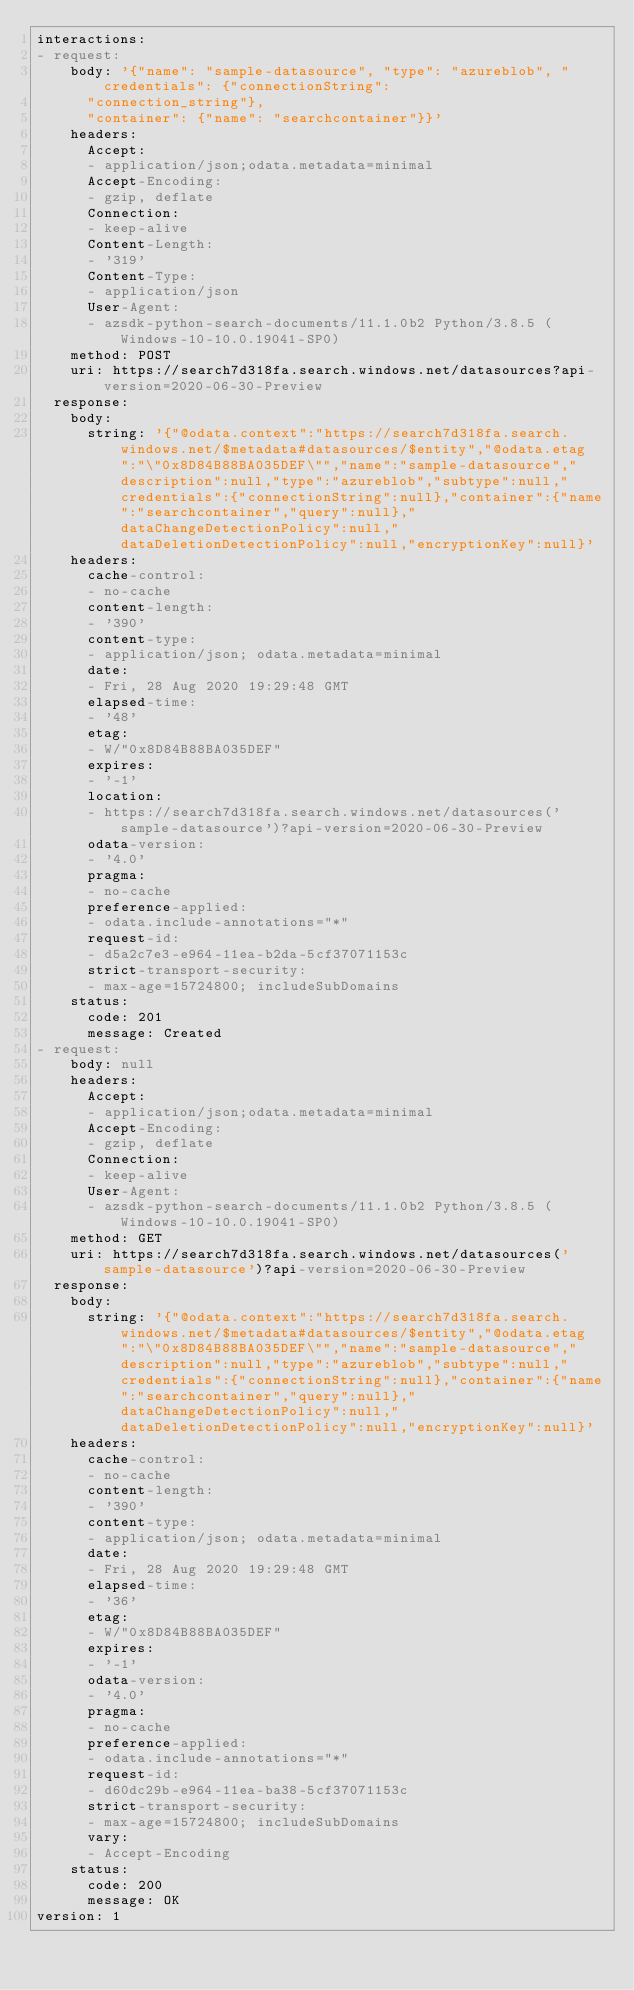Convert code to text. <code><loc_0><loc_0><loc_500><loc_500><_YAML_>interactions:
- request:
    body: '{"name": "sample-datasource", "type": "azureblob", "credentials": {"connectionString":
      "connection_string"},
      "container": {"name": "searchcontainer"}}'
    headers:
      Accept:
      - application/json;odata.metadata=minimal
      Accept-Encoding:
      - gzip, deflate
      Connection:
      - keep-alive
      Content-Length:
      - '319'
      Content-Type:
      - application/json
      User-Agent:
      - azsdk-python-search-documents/11.1.0b2 Python/3.8.5 (Windows-10-10.0.19041-SP0)
    method: POST
    uri: https://search7d318fa.search.windows.net/datasources?api-version=2020-06-30-Preview
  response:
    body:
      string: '{"@odata.context":"https://search7d318fa.search.windows.net/$metadata#datasources/$entity","@odata.etag":"\"0x8D84B88BA035DEF\"","name":"sample-datasource","description":null,"type":"azureblob","subtype":null,"credentials":{"connectionString":null},"container":{"name":"searchcontainer","query":null},"dataChangeDetectionPolicy":null,"dataDeletionDetectionPolicy":null,"encryptionKey":null}'
    headers:
      cache-control:
      - no-cache
      content-length:
      - '390'
      content-type:
      - application/json; odata.metadata=minimal
      date:
      - Fri, 28 Aug 2020 19:29:48 GMT
      elapsed-time:
      - '48'
      etag:
      - W/"0x8D84B88BA035DEF"
      expires:
      - '-1'
      location:
      - https://search7d318fa.search.windows.net/datasources('sample-datasource')?api-version=2020-06-30-Preview
      odata-version:
      - '4.0'
      pragma:
      - no-cache
      preference-applied:
      - odata.include-annotations="*"
      request-id:
      - d5a2c7e3-e964-11ea-b2da-5cf37071153c
      strict-transport-security:
      - max-age=15724800; includeSubDomains
    status:
      code: 201
      message: Created
- request:
    body: null
    headers:
      Accept:
      - application/json;odata.metadata=minimal
      Accept-Encoding:
      - gzip, deflate
      Connection:
      - keep-alive
      User-Agent:
      - azsdk-python-search-documents/11.1.0b2 Python/3.8.5 (Windows-10-10.0.19041-SP0)
    method: GET
    uri: https://search7d318fa.search.windows.net/datasources('sample-datasource')?api-version=2020-06-30-Preview
  response:
    body:
      string: '{"@odata.context":"https://search7d318fa.search.windows.net/$metadata#datasources/$entity","@odata.etag":"\"0x8D84B88BA035DEF\"","name":"sample-datasource","description":null,"type":"azureblob","subtype":null,"credentials":{"connectionString":null},"container":{"name":"searchcontainer","query":null},"dataChangeDetectionPolicy":null,"dataDeletionDetectionPolicy":null,"encryptionKey":null}'
    headers:
      cache-control:
      - no-cache
      content-length:
      - '390'
      content-type:
      - application/json; odata.metadata=minimal
      date:
      - Fri, 28 Aug 2020 19:29:48 GMT
      elapsed-time:
      - '36'
      etag:
      - W/"0x8D84B88BA035DEF"
      expires:
      - '-1'
      odata-version:
      - '4.0'
      pragma:
      - no-cache
      preference-applied:
      - odata.include-annotations="*"
      request-id:
      - d60dc29b-e964-11ea-ba38-5cf37071153c
      strict-transport-security:
      - max-age=15724800; includeSubDomains
      vary:
      - Accept-Encoding
    status:
      code: 200
      message: OK
version: 1
</code> 